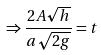<formula> <loc_0><loc_0><loc_500><loc_500>\Rightarrow \frac { 2 A \sqrt { h } } { a \sqrt { 2 g } } = t</formula> 